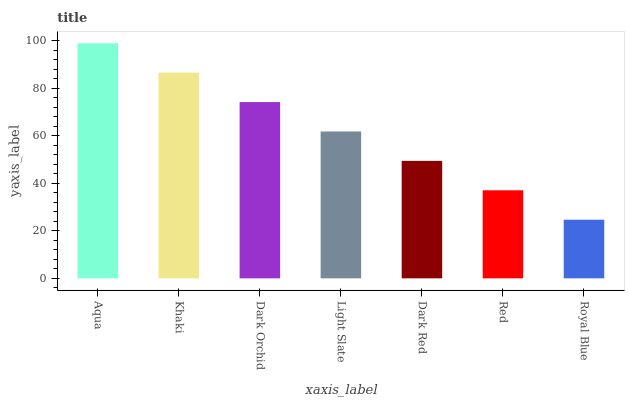Is Royal Blue the minimum?
Answer yes or no. Yes. Is Aqua the maximum?
Answer yes or no. Yes. Is Khaki the minimum?
Answer yes or no. No. Is Khaki the maximum?
Answer yes or no. No. Is Aqua greater than Khaki?
Answer yes or no. Yes. Is Khaki less than Aqua?
Answer yes or no. Yes. Is Khaki greater than Aqua?
Answer yes or no. No. Is Aqua less than Khaki?
Answer yes or no. No. Is Light Slate the high median?
Answer yes or no. Yes. Is Light Slate the low median?
Answer yes or no. Yes. Is Royal Blue the high median?
Answer yes or no. No. Is Dark Orchid the low median?
Answer yes or no. No. 